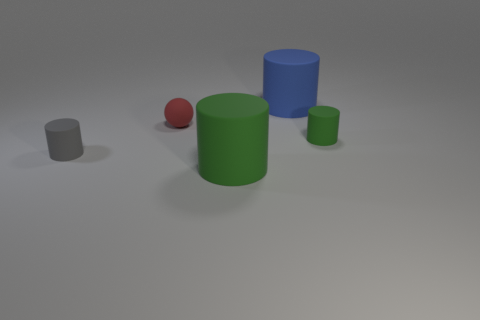Subtract all gray cylinders. How many cylinders are left? 3 Subtract all green cylinders. How many cylinders are left? 2 Subtract all balls. How many objects are left? 4 Add 4 green cylinders. How many objects exist? 9 Subtract 3 cylinders. How many cylinders are left? 1 Subtract all purple balls. Subtract all red cubes. How many balls are left? 1 Subtract all cyan cylinders. How many yellow balls are left? 0 Subtract all green things. Subtract all red spheres. How many objects are left? 2 Add 2 gray matte cylinders. How many gray matte cylinders are left? 3 Add 2 green matte cylinders. How many green matte cylinders exist? 4 